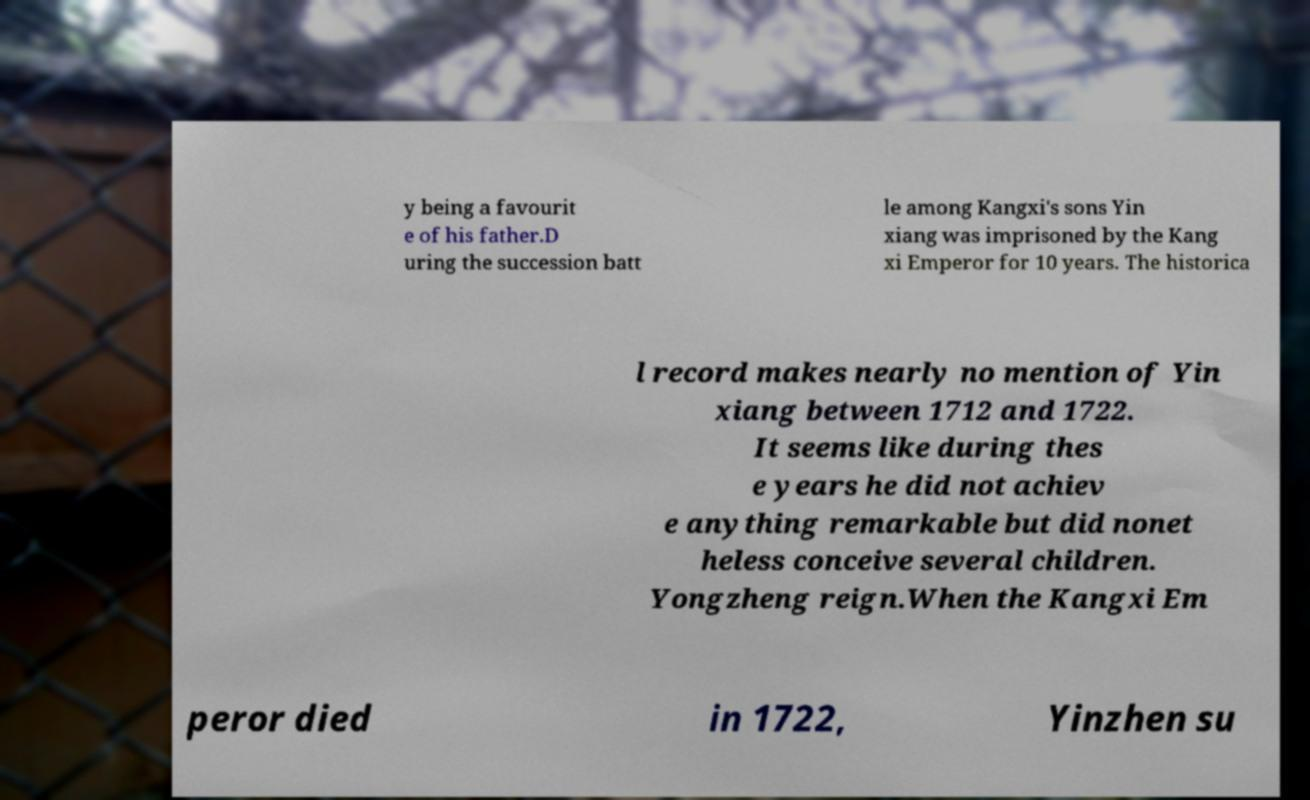Can you accurately transcribe the text from the provided image for me? y being a favourit e of his father.D uring the succession batt le among Kangxi's sons Yin xiang was imprisoned by the Kang xi Emperor for 10 years. The historica l record makes nearly no mention of Yin xiang between 1712 and 1722. It seems like during thes e years he did not achiev e anything remarkable but did nonet heless conceive several children. Yongzheng reign.When the Kangxi Em peror died in 1722, Yinzhen su 